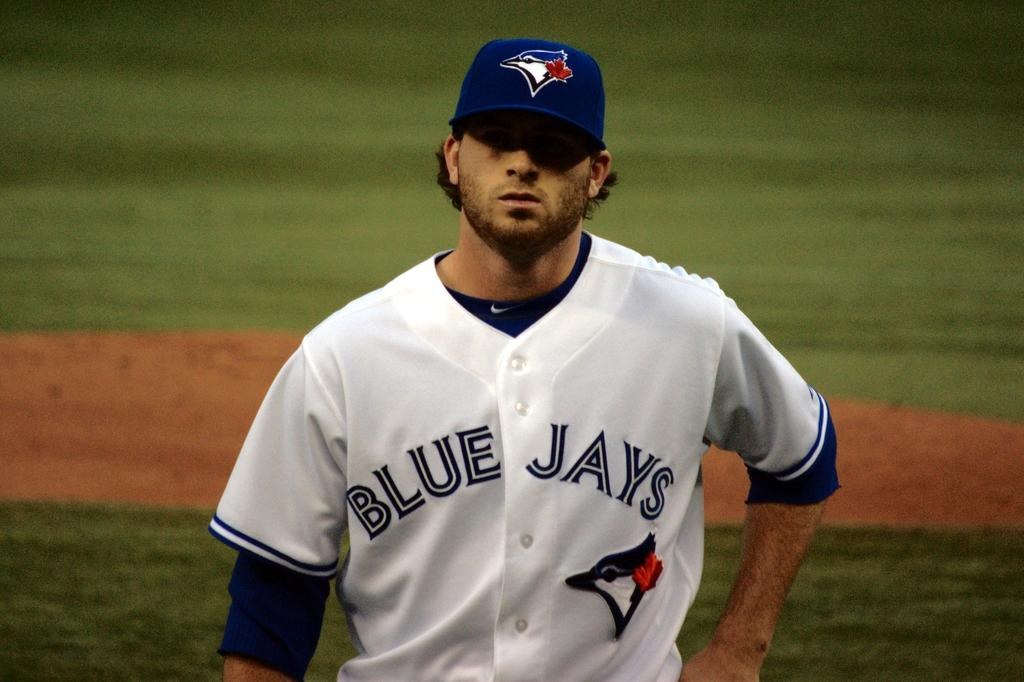<image>
Describe the image concisely. A baseball player is standing on the field and his uniform says Blue Jays. 